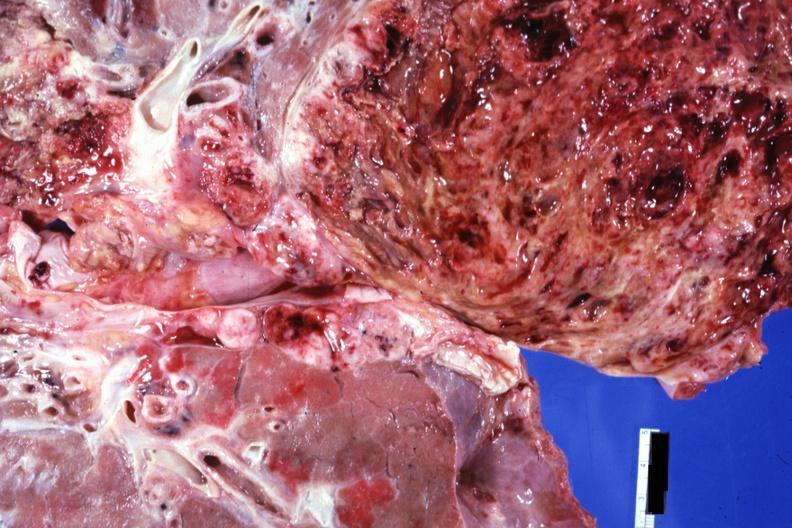what is present?
Answer the question using a single word or phrase. Thorax 